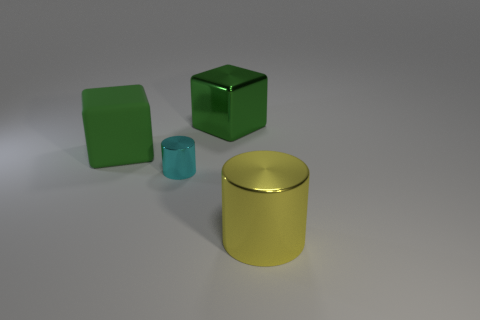Add 2 blocks. How many objects exist? 6 Subtract all gray cylinders. Subtract all red cubes. How many cylinders are left? 2 Subtract all green cubes. How many brown cylinders are left? 0 Subtract all cyan shiny cylinders. Subtract all yellow cylinders. How many objects are left? 2 Add 1 green metal objects. How many green metal objects are left? 2 Add 2 green cubes. How many green cubes exist? 4 Subtract all cyan cylinders. How many cylinders are left? 1 Subtract 0 purple cylinders. How many objects are left? 4 